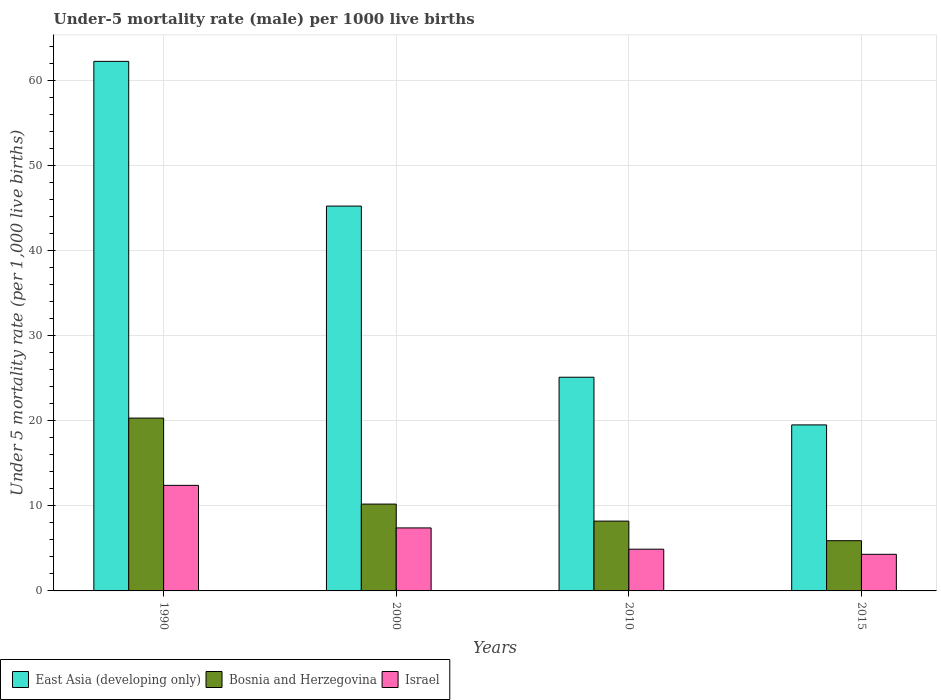How many different coloured bars are there?
Keep it short and to the point. 3. How many groups of bars are there?
Offer a terse response. 4. Are the number of bars per tick equal to the number of legend labels?
Give a very brief answer. Yes. Are the number of bars on each tick of the X-axis equal?
Make the answer very short. Yes. What is the label of the 4th group of bars from the left?
Make the answer very short. 2015. In how many cases, is the number of bars for a given year not equal to the number of legend labels?
Keep it short and to the point. 0. In which year was the under-five mortality rate in Israel minimum?
Offer a very short reply. 2015. What is the total under-five mortality rate in Bosnia and Herzegovina in the graph?
Your answer should be very brief. 44.6. What is the difference between the under-five mortality rate in Bosnia and Herzegovina in 1990 and that in 2000?
Your answer should be very brief. 10.1. What is the difference between the under-five mortality rate in Israel in 2000 and the under-five mortality rate in Bosnia and Herzegovina in 2010?
Provide a short and direct response. -0.8. What is the average under-five mortality rate in East Asia (developing only) per year?
Offer a terse response. 38. In the year 2010, what is the difference between the under-five mortality rate in Israel and under-five mortality rate in East Asia (developing only)?
Your response must be concise. -20.2. What is the ratio of the under-five mortality rate in Bosnia and Herzegovina in 2000 to that in 2015?
Offer a terse response. 1.73. What is the difference between the highest and the second highest under-five mortality rate in East Asia (developing only)?
Ensure brevity in your answer.  17. What is the difference between the highest and the lowest under-five mortality rate in Israel?
Provide a succinct answer. 8.1. What does the 2nd bar from the left in 2015 represents?
Offer a terse response. Bosnia and Herzegovina. How many bars are there?
Your answer should be compact. 12. Are the values on the major ticks of Y-axis written in scientific E-notation?
Offer a terse response. No. Does the graph contain any zero values?
Make the answer very short. No. How are the legend labels stacked?
Keep it short and to the point. Horizontal. What is the title of the graph?
Your answer should be very brief. Under-5 mortality rate (male) per 1000 live births. Does "Algeria" appear as one of the legend labels in the graph?
Your answer should be compact. No. What is the label or title of the X-axis?
Your answer should be very brief. Years. What is the label or title of the Y-axis?
Make the answer very short. Under 5 mortality rate (per 1,0 live births). What is the Under 5 mortality rate (per 1,000 live births) of East Asia (developing only) in 1990?
Make the answer very short. 62.2. What is the Under 5 mortality rate (per 1,000 live births) of Bosnia and Herzegovina in 1990?
Make the answer very short. 20.3. What is the Under 5 mortality rate (per 1,000 live births) in Israel in 1990?
Make the answer very short. 12.4. What is the Under 5 mortality rate (per 1,000 live births) in East Asia (developing only) in 2000?
Your answer should be very brief. 45.2. What is the Under 5 mortality rate (per 1,000 live births) in Bosnia and Herzegovina in 2000?
Offer a very short reply. 10.2. What is the Under 5 mortality rate (per 1,000 live births) of East Asia (developing only) in 2010?
Make the answer very short. 25.1. What is the Under 5 mortality rate (per 1,000 live births) of Bosnia and Herzegovina in 2015?
Your response must be concise. 5.9. Across all years, what is the maximum Under 5 mortality rate (per 1,000 live births) of East Asia (developing only)?
Offer a very short reply. 62.2. Across all years, what is the maximum Under 5 mortality rate (per 1,000 live births) of Bosnia and Herzegovina?
Your response must be concise. 20.3. Across all years, what is the minimum Under 5 mortality rate (per 1,000 live births) of East Asia (developing only)?
Offer a very short reply. 19.5. Across all years, what is the minimum Under 5 mortality rate (per 1,000 live births) in Israel?
Provide a succinct answer. 4.3. What is the total Under 5 mortality rate (per 1,000 live births) of East Asia (developing only) in the graph?
Offer a terse response. 152. What is the total Under 5 mortality rate (per 1,000 live births) in Bosnia and Herzegovina in the graph?
Your answer should be very brief. 44.6. What is the total Under 5 mortality rate (per 1,000 live births) of Israel in the graph?
Your answer should be very brief. 29. What is the difference between the Under 5 mortality rate (per 1,000 live births) of Bosnia and Herzegovina in 1990 and that in 2000?
Offer a very short reply. 10.1. What is the difference between the Under 5 mortality rate (per 1,000 live births) in Israel in 1990 and that in 2000?
Provide a succinct answer. 5. What is the difference between the Under 5 mortality rate (per 1,000 live births) in East Asia (developing only) in 1990 and that in 2010?
Offer a very short reply. 37.1. What is the difference between the Under 5 mortality rate (per 1,000 live births) in Bosnia and Herzegovina in 1990 and that in 2010?
Your response must be concise. 12.1. What is the difference between the Under 5 mortality rate (per 1,000 live births) in East Asia (developing only) in 1990 and that in 2015?
Offer a terse response. 42.7. What is the difference between the Under 5 mortality rate (per 1,000 live births) in East Asia (developing only) in 2000 and that in 2010?
Your answer should be very brief. 20.1. What is the difference between the Under 5 mortality rate (per 1,000 live births) of Israel in 2000 and that in 2010?
Give a very brief answer. 2.5. What is the difference between the Under 5 mortality rate (per 1,000 live births) in East Asia (developing only) in 2000 and that in 2015?
Provide a short and direct response. 25.7. What is the difference between the Under 5 mortality rate (per 1,000 live births) of Bosnia and Herzegovina in 2000 and that in 2015?
Make the answer very short. 4.3. What is the difference between the Under 5 mortality rate (per 1,000 live births) in Israel in 2000 and that in 2015?
Provide a succinct answer. 3.1. What is the difference between the Under 5 mortality rate (per 1,000 live births) of East Asia (developing only) in 2010 and that in 2015?
Keep it short and to the point. 5.6. What is the difference between the Under 5 mortality rate (per 1,000 live births) in East Asia (developing only) in 1990 and the Under 5 mortality rate (per 1,000 live births) in Bosnia and Herzegovina in 2000?
Your answer should be very brief. 52. What is the difference between the Under 5 mortality rate (per 1,000 live births) in East Asia (developing only) in 1990 and the Under 5 mortality rate (per 1,000 live births) in Israel in 2000?
Your answer should be compact. 54.8. What is the difference between the Under 5 mortality rate (per 1,000 live births) in East Asia (developing only) in 1990 and the Under 5 mortality rate (per 1,000 live births) in Bosnia and Herzegovina in 2010?
Give a very brief answer. 54. What is the difference between the Under 5 mortality rate (per 1,000 live births) in East Asia (developing only) in 1990 and the Under 5 mortality rate (per 1,000 live births) in Israel in 2010?
Make the answer very short. 57.3. What is the difference between the Under 5 mortality rate (per 1,000 live births) in Bosnia and Herzegovina in 1990 and the Under 5 mortality rate (per 1,000 live births) in Israel in 2010?
Provide a succinct answer. 15.4. What is the difference between the Under 5 mortality rate (per 1,000 live births) of East Asia (developing only) in 1990 and the Under 5 mortality rate (per 1,000 live births) of Bosnia and Herzegovina in 2015?
Your response must be concise. 56.3. What is the difference between the Under 5 mortality rate (per 1,000 live births) in East Asia (developing only) in 1990 and the Under 5 mortality rate (per 1,000 live births) in Israel in 2015?
Keep it short and to the point. 57.9. What is the difference between the Under 5 mortality rate (per 1,000 live births) of East Asia (developing only) in 2000 and the Under 5 mortality rate (per 1,000 live births) of Bosnia and Herzegovina in 2010?
Your response must be concise. 37. What is the difference between the Under 5 mortality rate (per 1,000 live births) in East Asia (developing only) in 2000 and the Under 5 mortality rate (per 1,000 live births) in Israel in 2010?
Make the answer very short. 40.3. What is the difference between the Under 5 mortality rate (per 1,000 live births) in East Asia (developing only) in 2000 and the Under 5 mortality rate (per 1,000 live births) in Bosnia and Herzegovina in 2015?
Make the answer very short. 39.3. What is the difference between the Under 5 mortality rate (per 1,000 live births) of East Asia (developing only) in 2000 and the Under 5 mortality rate (per 1,000 live births) of Israel in 2015?
Ensure brevity in your answer.  40.9. What is the difference between the Under 5 mortality rate (per 1,000 live births) in East Asia (developing only) in 2010 and the Under 5 mortality rate (per 1,000 live births) in Bosnia and Herzegovina in 2015?
Your answer should be very brief. 19.2. What is the difference between the Under 5 mortality rate (per 1,000 live births) of East Asia (developing only) in 2010 and the Under 5 mortality rate (per 1,000 live births) of Israel in 2015?
Your answer should be compact. 20.8. What is the difference between the Under 5 mortality rate (per 1,000 live births) in Bosnia and Herzegovina in 2010 and the Under 5 mortality rate (per 1,000 live births) in Israel in 2015?
Keep it short and to the point. 3.9. What is the average Under 5 mortality rate (per 1,000 live births) of East Asia (developing only) per year?
Your answer should be compact. 38. What is the average Under 5 mortality rate (per 1,000 live births) in Bosnia and Herzegovina per year?
Ensure brevity in your answer.  11.15. What is the average Under 5 mortality rate (per 1,000 live births) of Israel per year?
Your answer should be compact. 7.25. In the year 1990, what is the difference between the Under 5 mortality rate (per 1,000 live births) of East Asia (developing only) and Under 5 mortality rate (per 1,000 live births) of Bosnia and Herzegovina?
Provide a short and direct response. 41.9. In the year 1990, what is the difference between the Under 5 mortality rate (per 1,000 live births) in East Asia (developing only) and Under 5 mortality rate (per 1,000 live births) in Israel?
Ensure brevity in your answer.  49.8. In the year 2000, what is the difference between the Under 5 mortality rate (per 1,000 live births) of East Asia (developing only) and Under 5 mortality rate (per 1,000 live births) of Israel?
Make the answer very short. 37.8. In the year 2010, what is the difference between the Under 5 mortality rate (per 1,000 live births) in East Asia (developing only) and Under 5 mortality rate (per 1,000 live births) in Israel?
Make the answer very short. 20.2. In the year 2010, what is the difference between the Under 5 mortality rate (per 1,000 live births) in Bosnia and Herzegovina and Under 5 mortality rate (per 1,000 live births) in Israel?
Ensure brevity in your answer.  3.3. In the year 2015, what is the difference between the Under 5 mortality rate (per 1,000 live births) in East Asia (developing only) and Under 5 mortality rate (per 1,000 live births) in Bosnia and Herzegovina?
Your answer should be compact. 13.6. In the year 2015, what is the difference between the Under 5 mortality rate (per 1,000 live births) in Bosnia and Herzegovina and Under 5 mortality rate (per 1,000 live births) in Israel?
Ensure brevity in your answer.  1.6. What is the ratio of the Under 5 mortality rate (per 1,000 live births) of East Asia (developing only) in 1990 to that in 2000?
Make the answer very short. 1.38. What is the ratio of the Under 5 mortality rate (per 1,000 live births) of Bosnia and Herzegovina in 1990 to that in 2000?
Offer a terse response. 1.99. What is the ratio of the Under 5 mortality rate (per 1,000 live births) of Israel in 1990 to that in 2000?
Offer a terse response. 1.68. What is the ratio of the Under 5 mortality rate (per 1,000 live births) of East Asia (developing only) in 1990 to that in 2010?
Keep it short and to the point. 2.48. What is the ratio of the Under 5 mortality rate (per 1,000 live births) in Bosnia and Herzegovina in 1990 to that in 2010?
Keep it short and to the point. 2.48. What is the ratio of the Under 5 mortality rate (per 1,000 live births) of Israel in 1990 to that in 2010?
Provide a short and direct response. 2.53. What is the ratio of the Under 5 mortality rate (per 1,000 live births) of East Asia (developing only) in 1990 to that in 2015?
Give a very brief answer. 3.19. What is the ratio of the Under 5 mortality rate (per 1,000 live births) of Bosnia and Herzegovina in 1990 to that in 2015?
Provide a short and direct response. 3.44. What is the ratio of the Under 5 mortality rate (per 1,000 live births) in Israel in 1990 to that in 2015?
Make the answer very short. 2.88. What is the ratio of the Under 5 mortality rate (per 1,000 live births) of East Asia (developing only) in 2000 to that in 2010?
Provide a succinct answer. 1.8. What is the ratio of the Under 5 mortality rate (per 1,000 live births) in Bosnia and Herzegovina in 2000 to that in 2010?
Offer a very short reply. 1.24. What is the ratio of the Under 5 mortality rate (per 1,000 live births) of Israel in 2000 to that in 2010?
Make the answer very short. 1.51. What is the ratio of the Under 5 mortality rate (per 1,000 live births) in East Asia (developing only) in 2000 to that in 2015?
Ensure brevity in your answer.  2.32. What is the ratio of the Under 5 mortality rate (per 1,000 live births) in Bosnia and Herzegovina in 2000 to that in 2015?
Make the answer very short. 1.73. What is the ratio of the Under 5 mortality rate (per 1,000 live births) of Israel in 2000 to that in 2015?
Your response must be concise. 1.72. What is the ratio of the Under 5 mortality rate (per 1,000 live births) of East Asia (developing only) in 2010 to that in 2015?
Make the answer very short. 1.29. What is the ratio of the Under 5 mortality rate (per 1,000 live births) in Bosnia and Herzegovina in 2010 to that in 2015?
Provide a succinct answer. 1.39. What is the ratio of the Under 5 mortality rate (per 1,000 live births) of Israel in 2010 to that in 2015?
Ensure brevity in your answer.  1.14. What is the difference between the highest and the second highest Under 5 mortality rate (per 1,000 live births) in East Asia (developing only)?
Your response must be concise. 17. What is the difference between the highest and the second highest Under 5 mortality rate (per 1,000 live births) in Israel?
Your answer should be very brief. 5. What is the difference between the highest and the lowest Under 5 mortality rate (per 1,000 live births) in East Asia (developing only)?
Provide a succinct answer. 42.7. What is the difference between the highest and the lowest Under 5 mortality rate (per 1,000 live births) of Israel?
Ensure brevity in your answer.  8.1. 